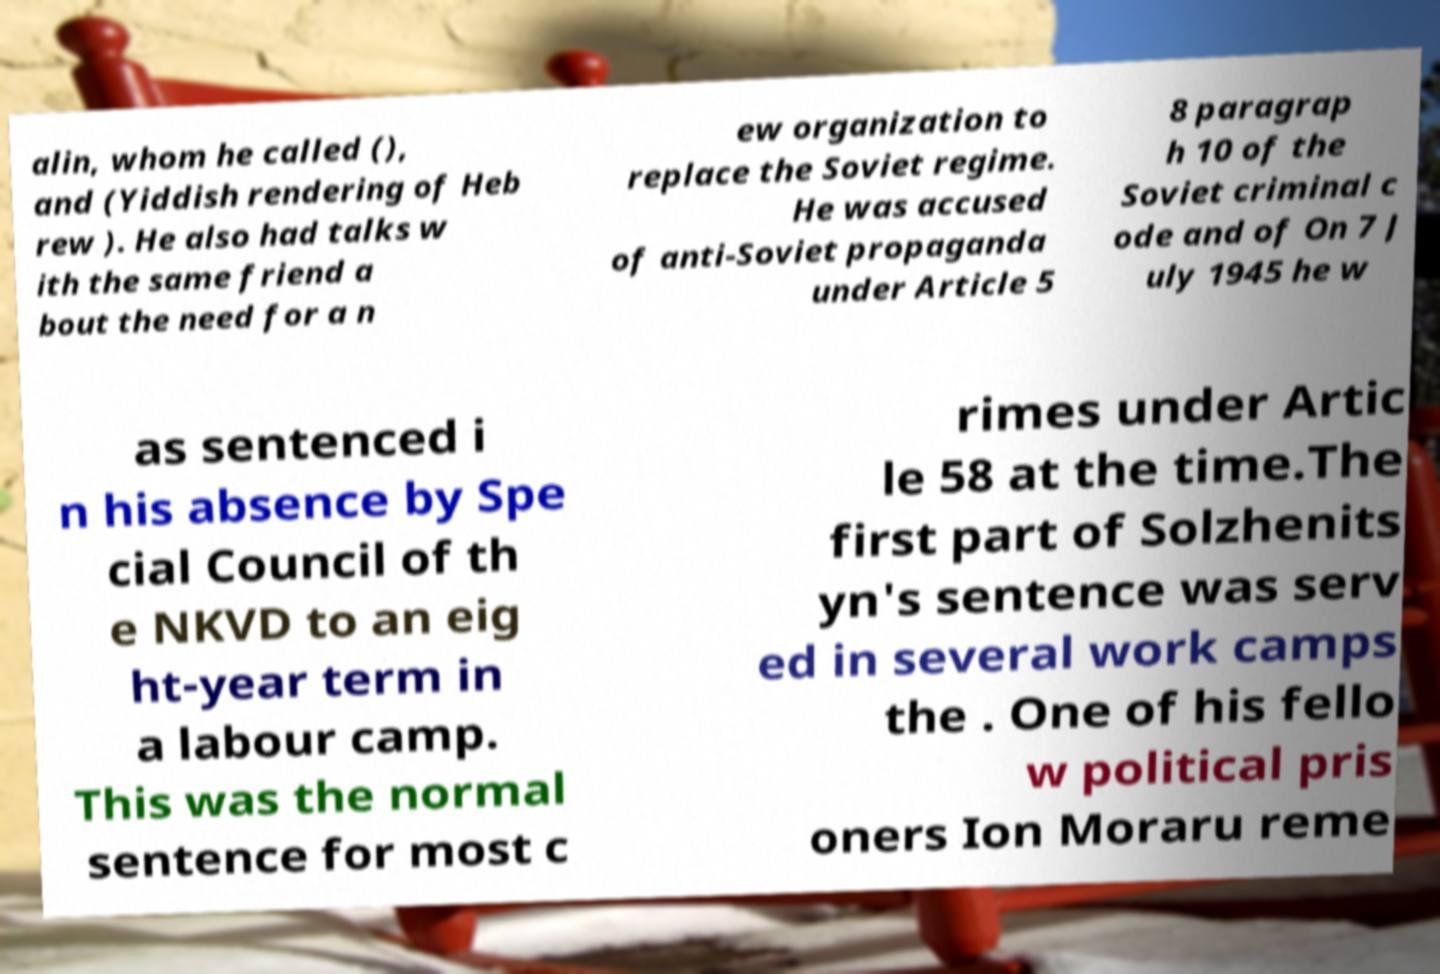What messages or text are displayed in this image? I need them in a readable, typed format. alin, whom he called (), and (Yiddish rendering of Heb rew ). He also had talks w ith the same friend a bout the need for a n ew organization to replace the Soviet regime. He was accused of anti-Soviet propaganda under Article 5 8 paragrap h 10 of the Soviet criminal c ode and of On 7 J uly 1945 he w as sentenced i n his absence by Spe cial Council of th e NKVD to an eig ht-year term in a labour camp. This was the normal sentence for most c rimes under Artic le 58 at the time.The first part of Solzhenits yn's sentence was serv ed in several work camps the . One of his fello w political pris oners Ion Moraru reme 